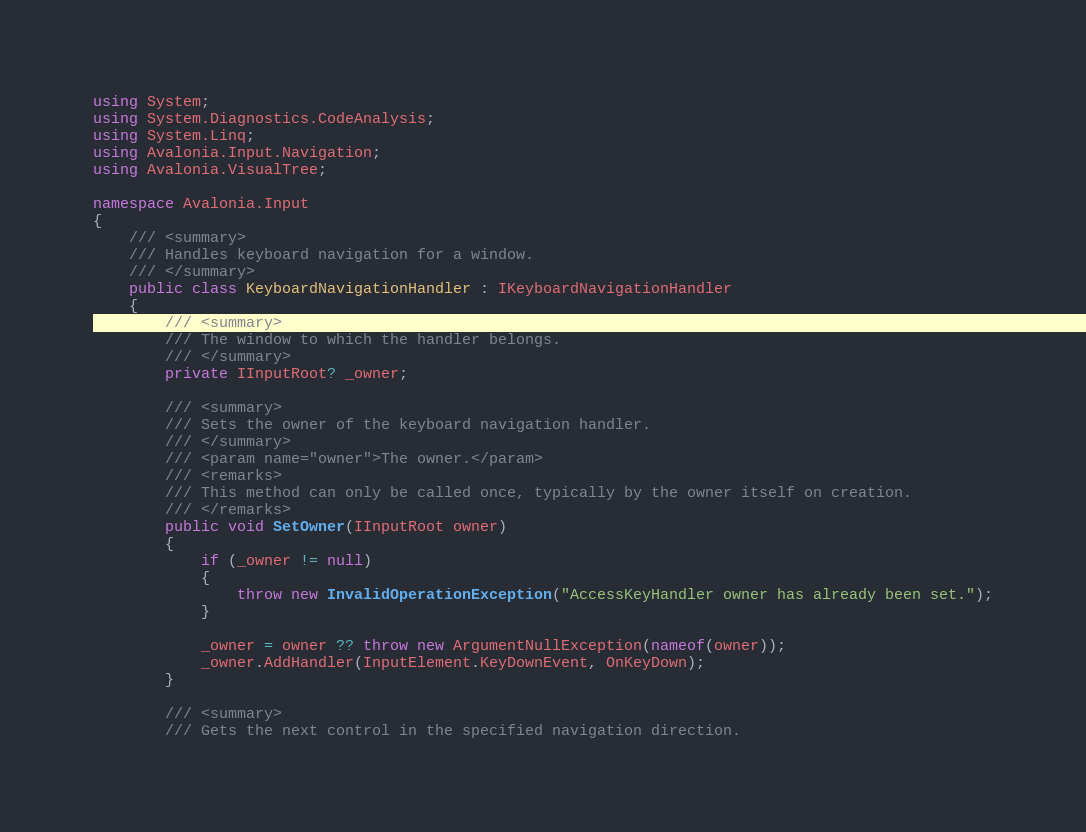<code> <loc_0><loc_0><loc_500><loc_500><_C#_>using System;
using System.Diagnostics.CodeAnalysis;
using System.Linq;
using Avalonia.Input.Navigation;
using Avalonia.VisualTree;

namespace Avalonia.Input
{
    /// <summary>
    /// Handles keyboard navigation for a window.
    /// </summary>
    public class KeyboardNavigationHandler : IKeyboardNavigationHandler
    {
        /// <summary>
        /// The window to which the handler belongs.
        /// </summary>
        private IInputRoot? _owner;

        /// <summary>
        /// Sets the owner of the keyboard navigation handler.
        /// </summary>
        /// <param name="owner">The owner.</param>
        /// <remarks>
        /// This method can only be called once, typically by the owner itself on creation.
        /// </remarks>
        public void SetOwner(IInputRoot owner)
        {
            if (_owner != null)
            {
                throw new InvalidOperationException("AccessKeyHandler owner has already been set.");
            }

            _owner = owner ?? throw new ArgumentNullException(nameof(owner));
            _owner.AddHandler(InputElement.KeyDownEvent, OnKeyDown);
        }

        /// <summary>
        /// Gets the next control in the specified navigation direction.</code> 